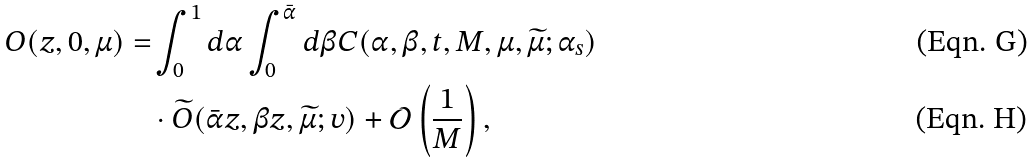Convert formula to latex. <formula><loc_0><loc_0><loc_500><loc_500>O ( z , 0 , \mu ) = & \int _ { 0 } ^ { 1 } d \alpha \int _ { 0 } ^ { \bar { \alpha } } d \beta C ( \alpha , \beta , t , M , \mu , \widetilde { \mu } ; \alpha _ { s } ) \\ & \cdot \widetilde { O } ( \bar { \alpha } z , \beta z , \widetilde { \mu } ; v ) + \mathcal { O } \left ( \frac { 1 } { M } \right ) ,</formula> 